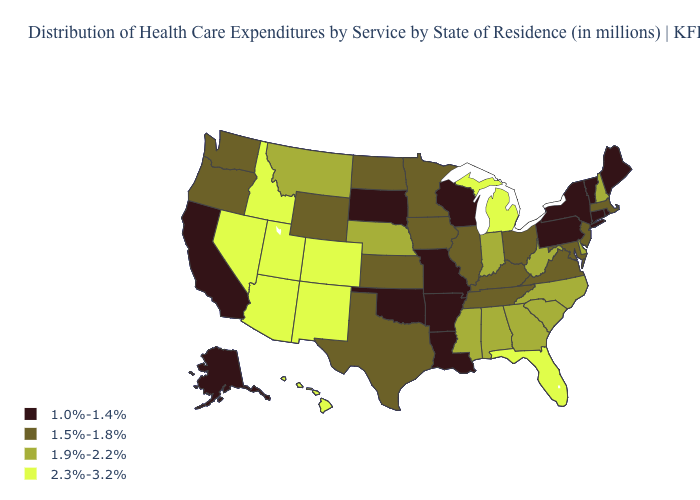Name the states that have a value in the range 1.9%-2.2%?
Concise answer only. Alabama, Delaware, Georgia, Indiana, Mississippi, Montana, Nebraska, New Hampshire, North Carolina, South Carolina, West Virginia. Name the states that have a value in the range 1.5%-1.8%?
Keep it brief. Illinois, Iowa, Kansas, Kentucky, Maryland, Massachusetts, Minnesota, New Jersey, North Dakota, Ohio, Oregon, Tennessee, Texas, Virginia, Washington, Wyoming. Does the map have missing data?
Short answer required. No. Which states have the lowest value in the MidWest?
Concise answer only. Missouri, South Dakota, Wisconsin. What is the lowest value in the USA?
Concise answer only. 1.0%-1.4%. Name the states that have a value in the range 2.3%-3.2%?
Write a very short answer. Arizona, Colorado, Florida, Hawaii, Idaho, Michigan, Nevada, New Mexico, Utah. Name the states that have a value in the range 1.0%-1.4%?
Concise answer only. Alaska, Arkansas, California, Connecticut, Louisiana, Maine, Missouri, New York, Oklahoma, Pennsylvania, Rhode Island, South Dakota, Vermont, Wisconsin. Name the states that have a value in the range 1.0%-1.4%?
Short answer required. Alaska, Arkansas, California, Connecticut, Louisiana, Maine, Missouri, New York, Oklahoma, Pennsylvania, Rhode Island, South Dakota, Vermont, Wisconsin. What is the lowest value in the USA?
Be succinct. 1.0%-1.4%. What is the value of Utah?
Write a very short answer. 2.3%-3.2%. Name the states that have a value in the range 1.9%-2.2%?
Give a very brief answer. Alabama, Delaware, Georgia, Indiana, Mississippi, Montana, Nebraska, New Hampshire, North Carolina, South Carolina, West Virginia. What is the lowest value in the MidWest?
Be succinct. 1.0%-1.4%. What is the lowest value in states that border Ohio?
Concise answer only. 1.0%-1.4%. How many symbols are there in the legend?
Short answer required. 4. Does Louisiana have the lowest value in the South?
Answer briefly. Yes. 